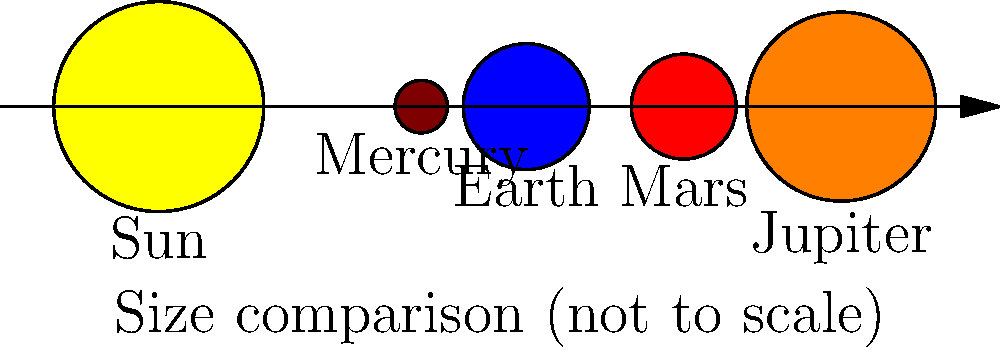While driving to your astronomy club meeting, you're reviewing planet sizes. Looking at the diagram, which planet is represented as the largest after the Sun? Let's analyze the diagram step-by-step:

1. The diagram shows five celestial bodies: the Sun and four planets.
2. The Sun is the largest object, represented by the yellow circle on the far left.
3. Moving from left to right, we see:
   - A small brown circle (Mercury)
   - A slightly larger blue circle (Earth)
   - A similar-sized red circle (Mars)
   - A much larger orange circle (Jupiter)
4. Comparing the sizes of the planets (excluding the Sun):
   - Mercury is the smallest
   - Earth and Mars are similar in size, both larger than Mercury
   - Jupiter is significantly larger than the other three planets

5. Therefore, among the planets shown, Jupiter is represented as the largest.

This diagram is not to scale but gives a general idea of the relative sizes. In reality, Jupiter is indeed the largest planet in our solar system, with a diameter about 11 times that of Earth.
Answer: Jupiter 